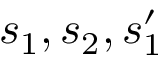<formula> <loc_0><loc_0><loc_500><loc_500>s _ { 1 } , s _ { 2 } , s _ { 1 } ^ { \prime }</formula> 